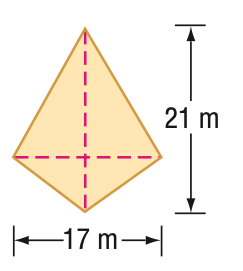Question: Find the area of the kite.
Choices:
A. 168
B. 177
C. 178.5
D. 357
Answer with the letter. Answer: C 